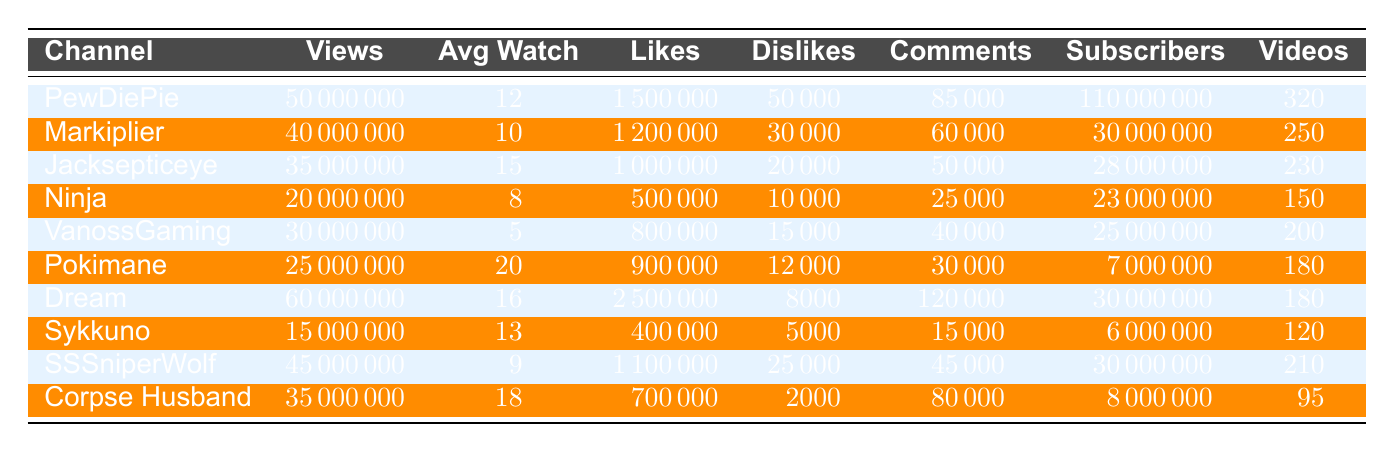What is the total number of views for PewDiePie? The table lists PewDiePie under the channel name along with the corresponding total views. From the table, the total views for PewDiePie are 50,000,000.
Answer: 50000000 Which channel has the highest average watch time? By comparing the average watch time across all channels, we see that Pokimane has the highest average watch time of 20 minutes.
Answer: Pokimane How many likes did Dream receive? The table shows Dream's channel along with the total likes received, which is 2,500,000.
Answer: 2500000 What is the total number of subscribers across all channels? To find the total number of subscribers, add the subscribers from each channel: 110000000 + 30000000 + 28000000 + 23000000 + 25000000 + 7000000 + 30000000 + 6000000 + 30000000 + 8000000 = 282000000.
Answer: 282000000 Which channel has the highest number of dislikes? Reviewing the dislike counts, PewDiePie has the highest dislikes at 50,000.
Answer: PewDiePie Is the average watch time for VanossGaming greater than 10 minutes? VanossGaming's average watch time is 5 minutes, which is less than 10 minutes, making the statement false.
Answer: No What is the ratio of likes to comments for Jacksepticeye? The likes for Jacksepticeye are 1,000,000 and comments are 50,000. The ratio is 1,000,000 / 50,000 = 20.
Answer: 20 Which two channels have total views of less than 30 million? From the table, both Ninja and VanossGaming have total views of 20,000,000 and 30,000,000 respectively, meaning they both qualify.
Answer: Ninja, VanossGaming What is the average average watch time for all channels? First, sum all average watch times: 12 + 10 + 15 + 8 + 5 + 20 + 16 + 13 + 9 + 18 = 132. Then divide this by the number of channels (10): 132 / 10 = 13.2.
Answer: 13.2 How many subscribers does Corpse Husband have compared to Ninja? Corpse Husband has 8,000,000 subscribers while Ninja has 23,000,000. Comparing these shows Corpse Husband has fewer subscribers.
Answer: Fewer 